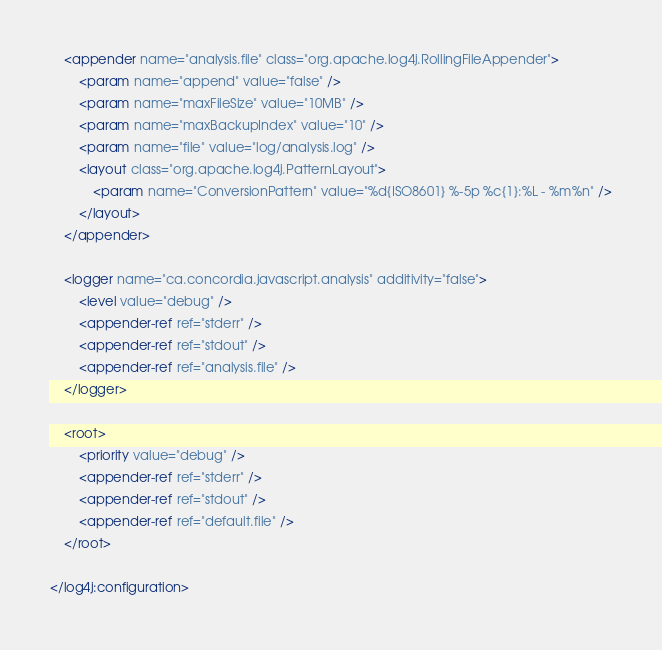Convert code to text. <code><loc_0><loc_0><loc_500><loc_500><_XML_>
	<appender name="analysis.file" class="org.apache.log4j.RollingFileAppender">
		<param name="append" value="false" />
		<param name="maxFileSize" value="10MB" />
		<param name="maxBackupIndex" value="10" />
		<param name="file" value="log/analysis.log" />
		<layout class="org.apache.log4j.PatternLayout">
			<param name="ConversionPattern" value="%d{ISO8601} %-5p %c{1}:%L - %m%n" />
		</layout>
	</appender>

	<logger name="ca.concordia.javascript.analysis" additivity="false">
		<level value="debug" />
		<appender-ref ref="stderr" />
		<appender-ref ref="stdout" />
		<appender-ref ref="analysis.file" />
	</logger>

	<root>
		<priority value="debug" />
		<appender-ref ref="stderr" />
		<appender-ref ref="stdout" />
		<appender-ref ref="default.file" />
	</root>

</log4j:configuration></code> 